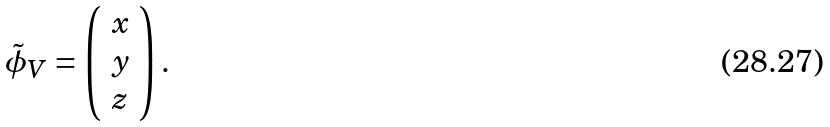<formula> <loc_0><loc_0><loc_500><loc_500>\tilde { \phi } _ { V } = \left ( \begin{array} { c } { x } \\ { y } \\ { z } \end{array} \right ) .</formula> 